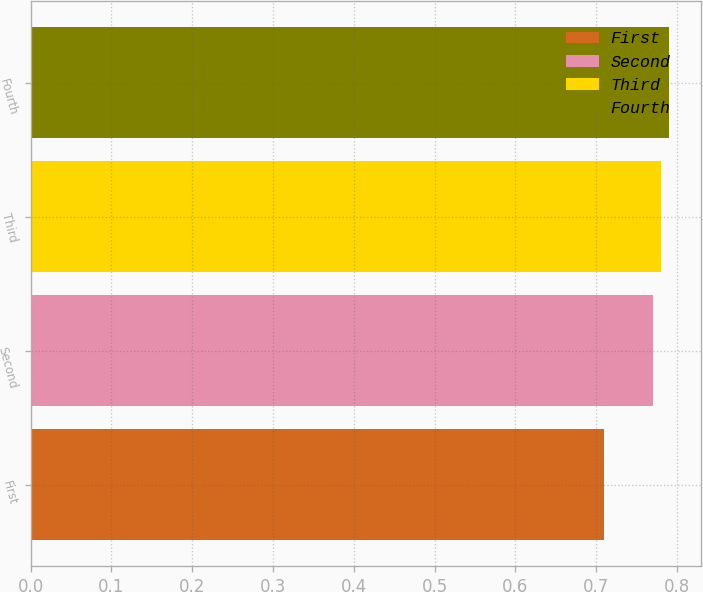Convert chart. <chart><loc_0><loc_0><loc_500><loc_500><bar_chart><fcel>First<fcel>Second<fcel>Third<fcel>Fourth<nl><fcel>0.71<fcel>0.77<fcel>0.78<fcel>0.79<nl></chart> 